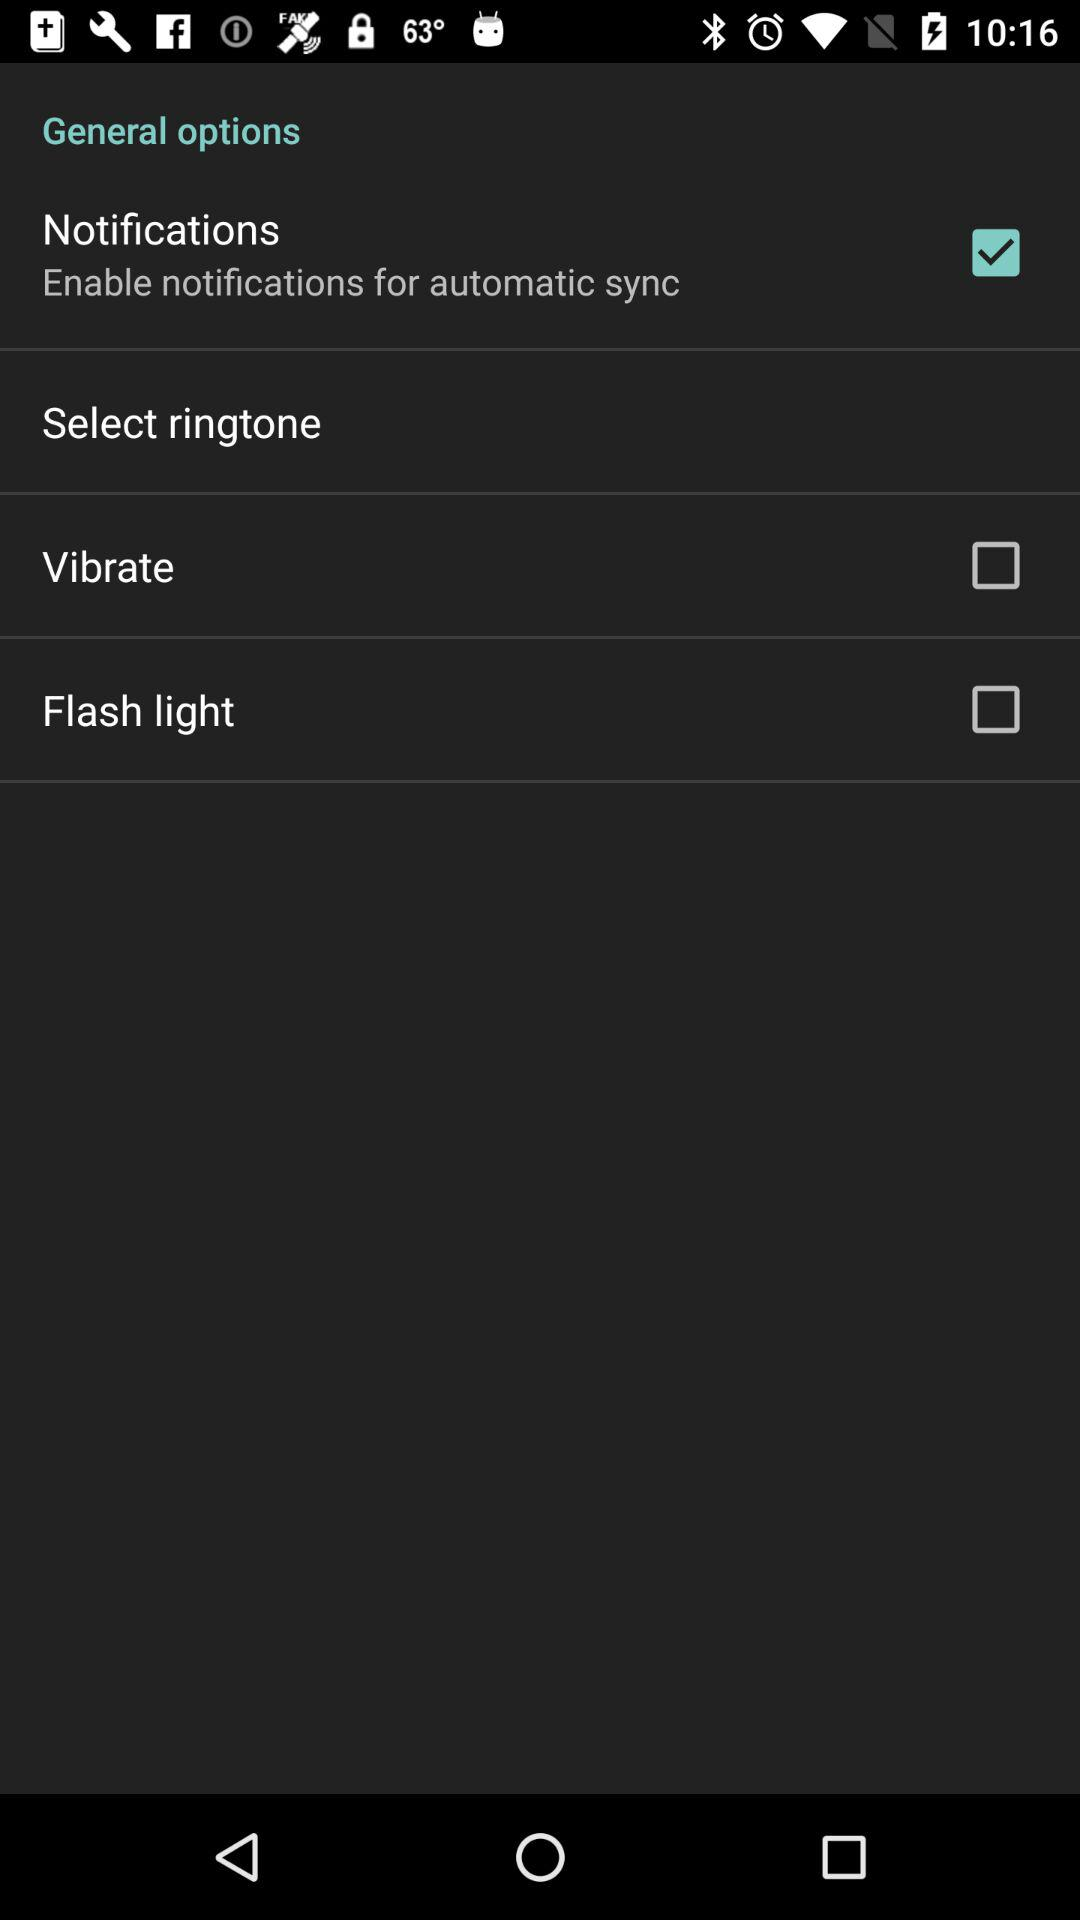How many items are in the General options section?
Answer the question using a single word or phrase. 4 